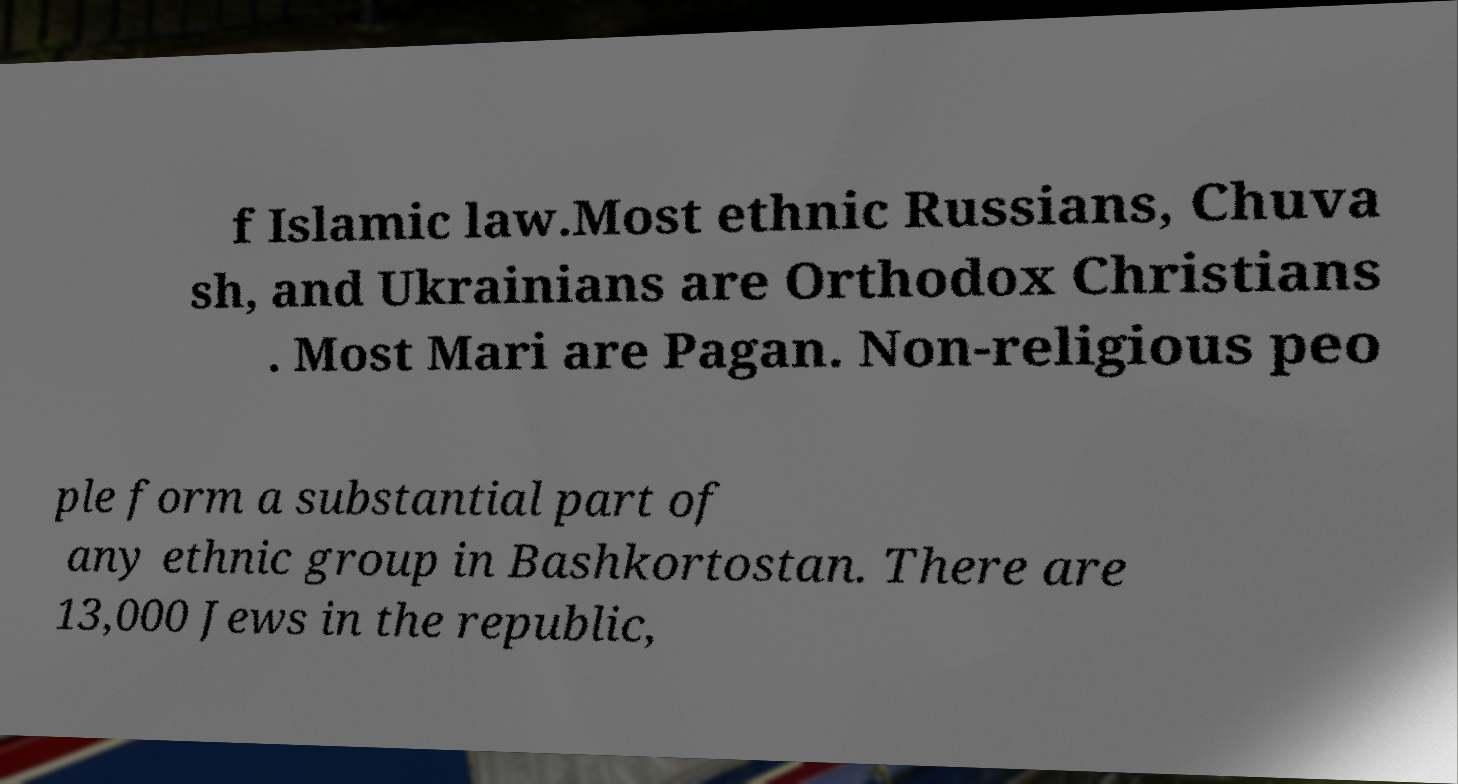There's text embedded in this image that I need extracted. Can you transcribe it verbatim? f Islamic law.Most ethnic Russians, Chuva sh, and Ukrainians are Orthodox Christians . Most Mari are Pagan. Non-religious peo ple form a substantial part of any ethnic group in Bashkortostan. There are 13,000 Jews in the republic, 